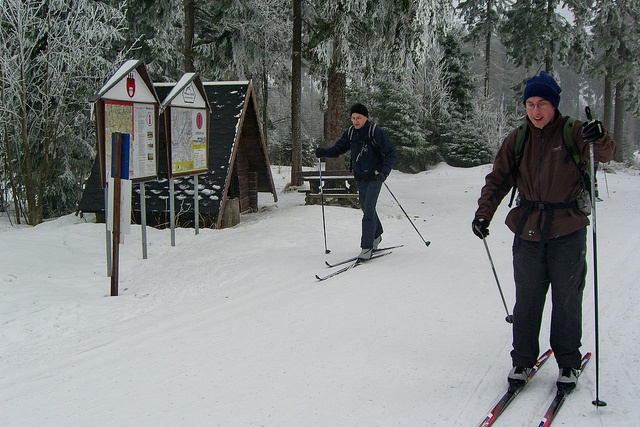Describe the objects in this image and their specific colors. I can see people in lightgray, black, gray, maroon, and brown tones, people in lightgray, black, gray, and brown tones, backpack in lightgray, black, gray, darkgreen, and darkgray tones, skis in lightgray, black, gray, purple, and maroon tones, and skis in lightgray, darkgray, gray, and black tones in this image. 